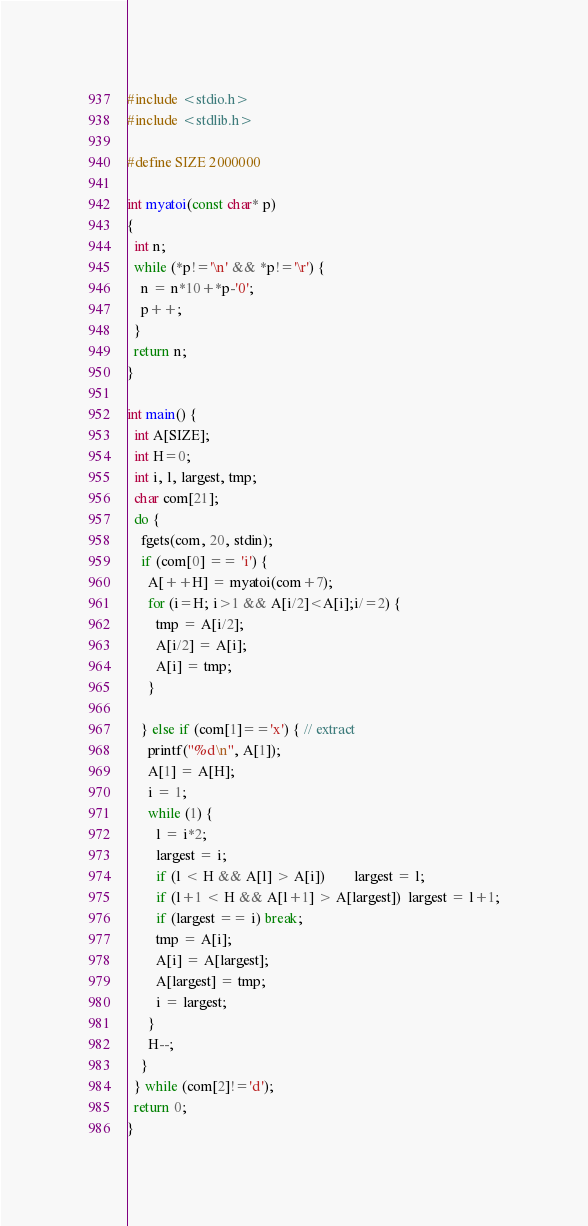<code> <loc_0><loc_0><loc_500><loc_500><_C_>#include <stdio.h>
#include <stdlib.h>

#define SIZE 2000000

int myatoi(const char* p)
{
  int n;
  while (*p!='\n' && *p!='\r') {
    n = n*10+*p-'0';
    p++;
  }
  return n;
}

int main() {
  int A[SIZE];
  int H=0;
  int i, l, largest, tmp;
  char com[21];
  do {
    fgets(com, 20, stdin);
    if (com[0] == 'i') {
      A[++H] = myatoi(com+7);
      for (i=H; i>1 && A[i/2]<A[i];i/=2) {
        tmp = A[i/2];
        A[i/2] = A[i];
        A[i] = tmp;
      }

    } else if (com[1]=='x') { // extract
      printf("%d\n", A[1]);
      A[1] = A[H];
      i = 1;
      while (1) {
        l = i*2;
        largest = i;
        if (l < H && A[l] > A[i])        largest = l;
        if (l+1 < H && A[l+1] > A[largest])  largest = l+1;
        if (largest == i) break;
        tmp = A[i];
        A[i] = A[largest];
        A[largest] = tmp;
        i = largest;
      }
      H--;
    }
  } while (com[2]!='d');
  return 0;
}
</code> 